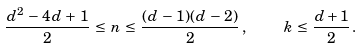<formula> <loc_0><loc_0><loc_500><loc_500>\frac { d ^ { 2 } \, - \, 4 d \, + \, 1 } { 2 } \, \leq \, n \, \leq \, \frac { ( d \, - \, 1 ) ( d \, - \, 2 ) } { 2 } \, , \quad \, k \, \leq \, \frac { d + 1 } { 2 } \, .</formula> 